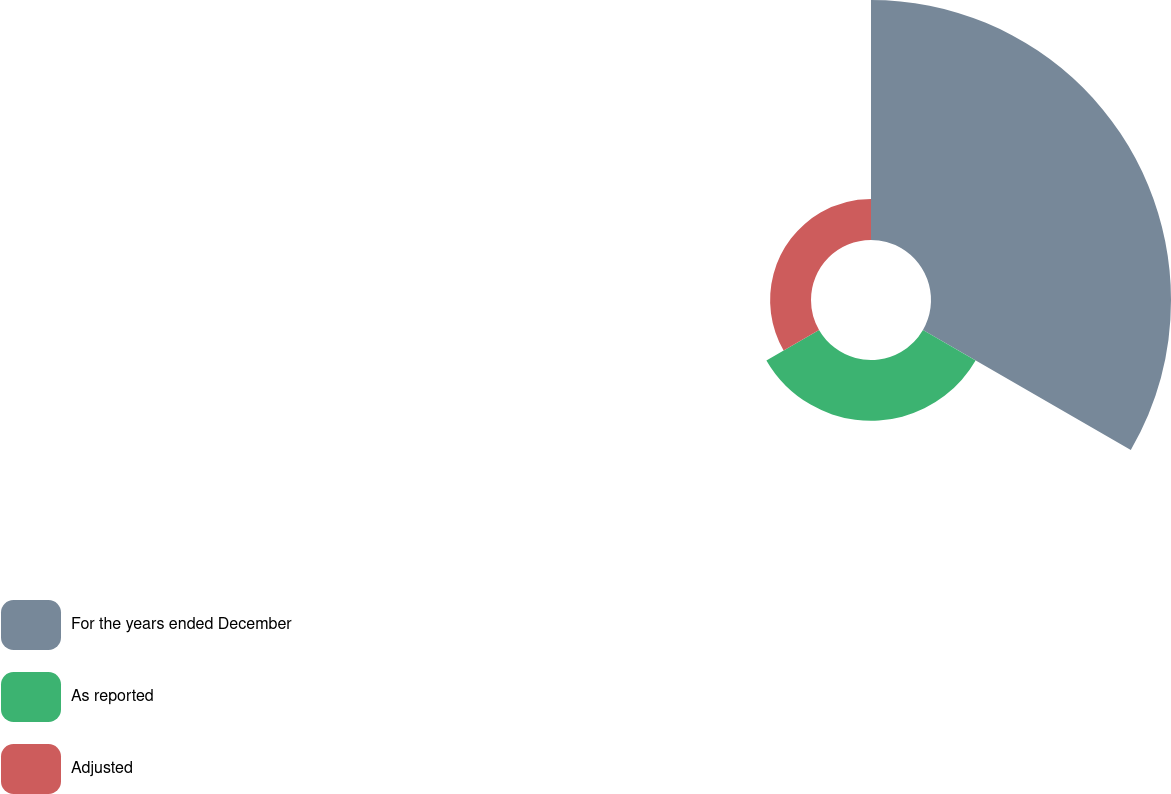Convert chart to OTSL. <chart><loc_0><loc_0><loc_500><loc_500><pie_chart><fcel>For the years ended December<fcel>As reported<fcel>Adjusted<nl><fcel>70.24%<fcel>17.79%<fcel>11.97%<nl></chart> 